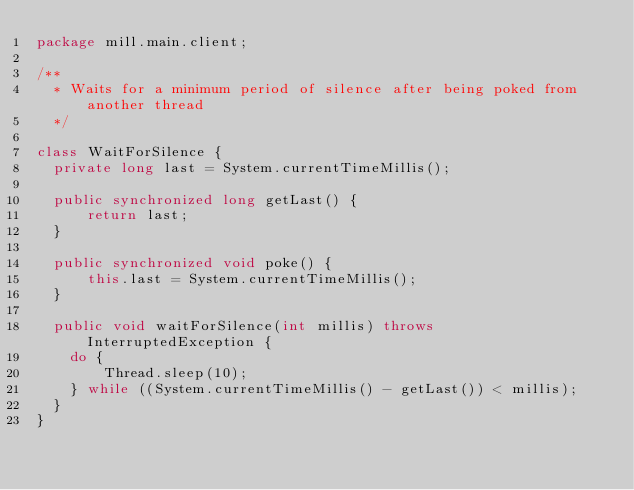<code> <loc_0><loc_0><loc_500><loc_500><_Java_>package mill.main.client;

/**
  * Waits for a minimum period of silence after being poked from another thread
  */

class WaitForSilence {
  private long last = System.currentTimeMillis();

  public synchronized long getLast() {
      return last;
  }

  public synchronized void poke() {
      this.last = System.currentTimeMillis();
  }

  public void waitForSilence(int millis) throws InterruptedException {
    do {
        Thread.sleep(10);
    } while ((System.currentTimeMillis() - getLast()) < millis);
  }
}
</code> 